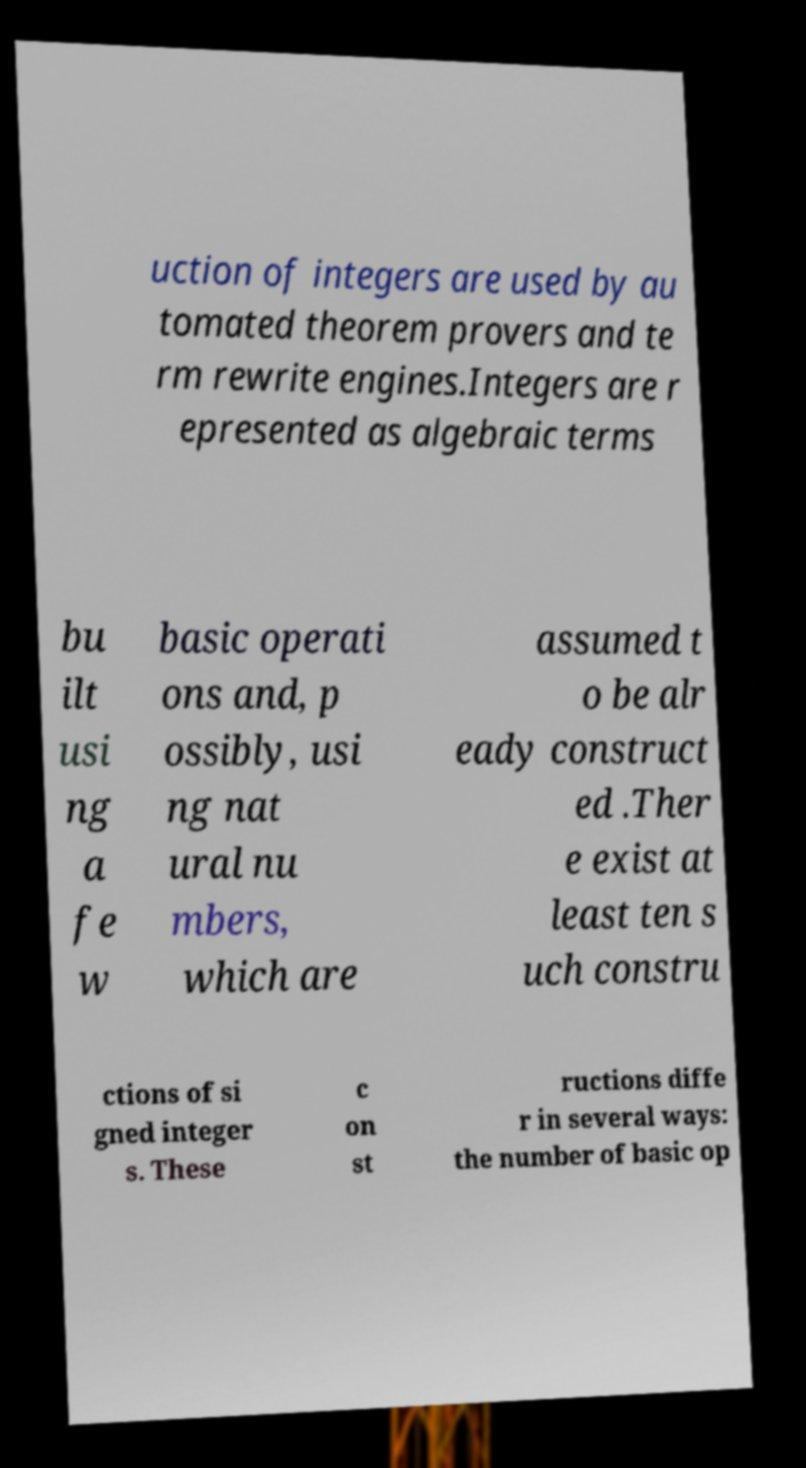I need the written content from this picture converted into text. Can you do that? uction of integers are used by au tomated theorem provers and te rm rewrite engines.Integers are r epresented as algebraic terms bu ilt usi ng a fe w basic operati ons and, p ossibly, usi ng nat ural nu mbers, which are assumed t o be alr eady construct ed .Ther e exist at least ten s uch constru ctions of si gned integer s. These c on st ructions diffe r in several ways: the number of basic op 